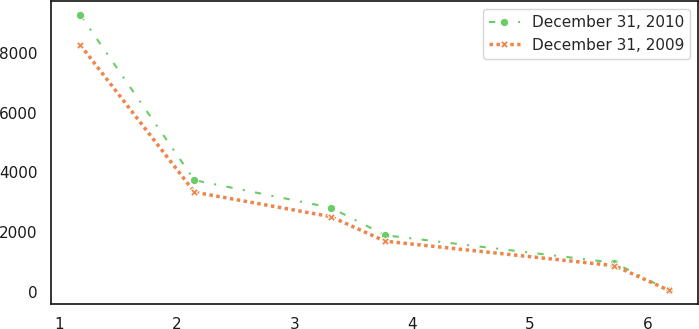Convert chart. <chart><loc_0><loc_0><loc_500><loc_500><line_chart><ecel><fcel>December 31, 2010<fcel>December 31, 2009<nl><fcel>1.18<fcel>9264.79<fcel>8260.76<nl><fcel>2.15<fcel>3742.85<fcel>3342.29<nl><fcel>3.31<fcel>2822.52<fcel>2522.55<nl><fcel>3.77<fcel>1902.19<fcel>1702.81<nl><fcel>5.72<fcel>981.86<fcel>883.07<nl><fcel>6.18<fcel>61.53<fcel>63.33<nl></chart> 